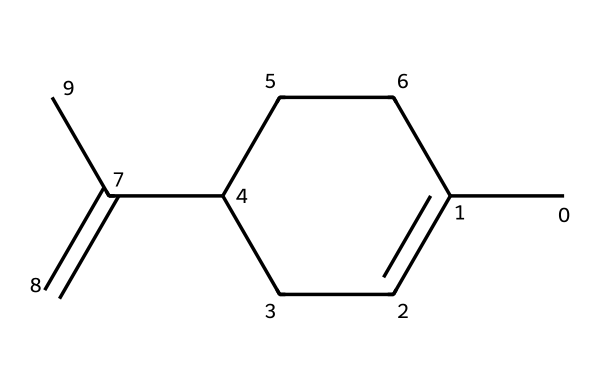What is the total number of carbon atoms in limonene? By inspecting the chemical structure represented by the SMILES string, we can count the number of "C" symbols, as each represents a carbon atom. Here, there are 10 carbon atoms.
Answer: 10 How many double bonds are present in limonene? The SMILES representation shows a "C(=C)" portion, indicating the presence of one double bond. We further verify that there is no other occurrence of "=" sign indicating additional double bonds.
Answer: 1 What type of isomerism might limonene exhibit? The presence of a double bond in limonene suggests that it can exist in different configurations (cis and trans) due to restricted rotation around the double bond, indicating potential geometric isomerism.
Answer: geometric isomerism What is the primary smell associated with limonene? Limonene is commonly known for its citrus scent. This characteristic is largely associated with its chemical structure and presence in citrus fruit peels.
Answer: citrus Which functional group contributes to the fragrance of limonene? The chemical structure contains alkenes, specifically due to the presence of the double bond in its carbon skeleton, which is a common feature in many fragrant compounds.
Answer: alkene How many rings are present in the structure of limonene? Analyzing the SMILES representations reveals a cyclic structure, specifically a cyclohexene ring within the compound. Hence, there is one ring in limonene's structure.
Answer: 1 